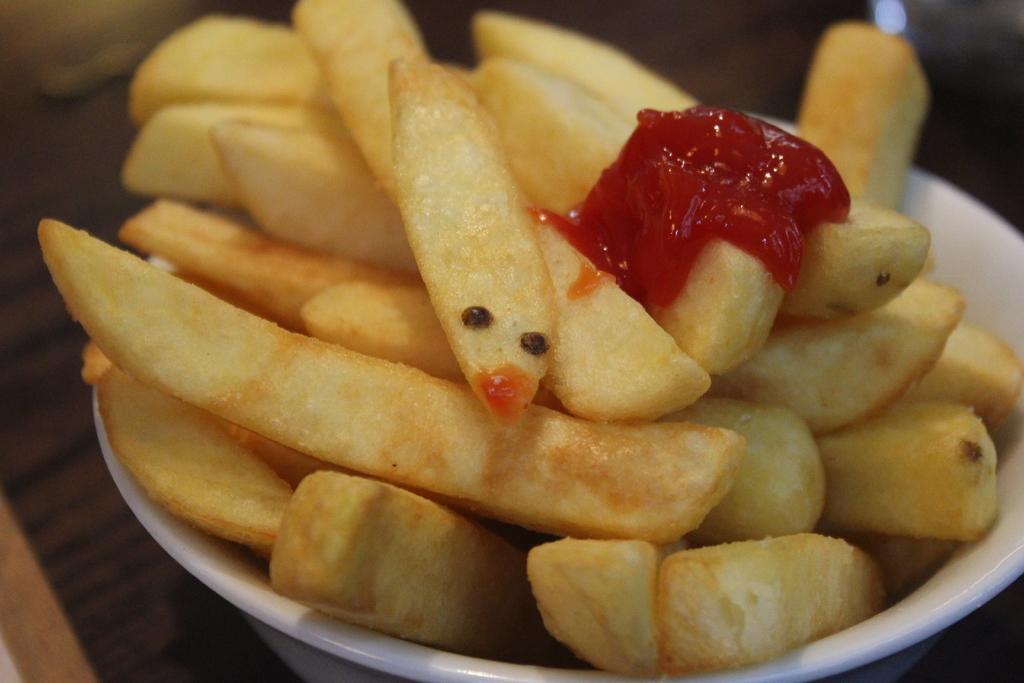Could you give a brief overview of what you see in this image? In this picture, we can see some food items served in a container. 